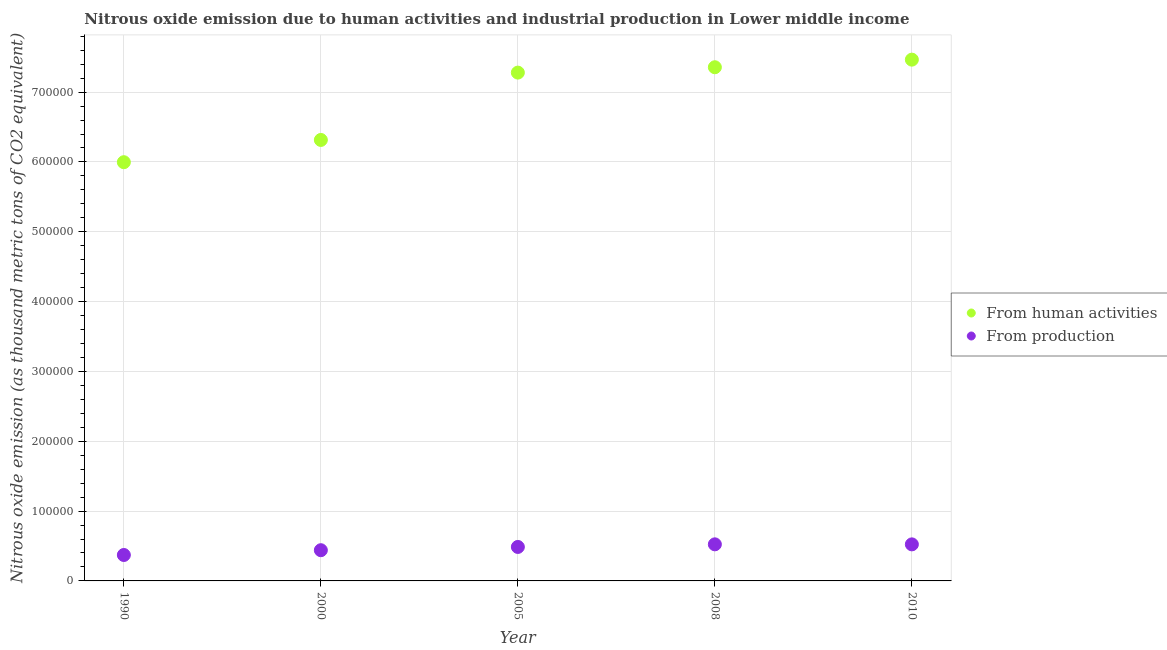What is the amount of emissions from human activities in 2000?
Your answer should be compact. 6.32e+05. Across all years, what is the maximum amount of emissions generated from industries?
Keep it short and to the point. 5.24e+04. Across all years, what is the minimum amount of emissions generated from industries?
Make the answer very short. 3.71e+04. What is the total amount of emissions from human activities in the graph?
Your answer should be very brief. 3.44e+06. What is the difference between the amount of emissions generated from industries in 2008 and that in 2010?
Provide a short and direct response. 45.3. What is the difference between the amount of emissions from human activities in 2010 and the amount of emissions generated from industries in 2005?
Your response must be concise. 6.98e+05. What is the average amount of emissions generated from industries per year?
Make the answer very short. 4.69e+04. In the year 2000, what is the difference between the amount of emissions generated from industries and amount of emissions from human activities?
Make the answer very short. -5.88e+05. In how many years, is the amount of emissions generated from industries greater than 740000 thousand metric tons?
Your answer should be very brief. 0. What is the ratio of the amount of emissions generated from industries in 2005 to that in 2010?
Give a very brief answer. 0.93. Is the amount of emissions from human activities in 2000 less than that in 2008?
Your response must be concise. Yes. What is the difference between the highest and the second highest amount of emissions from human activities?
Provide a succinct answer. 1.09e+04. What is the difference between the highest and the lowest amount of emissions from human activities?
Provide a succinct answer. 1.47e+05. In how many years, is the amount of emissions generated from industries greater than the average amount of emissions generated from industries taken over all years?
Your response must be concise. 3. Does the amount of emissions generated from industries monotonically increase over the years?
Offer a very short reply. No. Are the values on the major ticks of Y-axis written in scientific E-notation?
Offer a very short reply. No. Does the graph contain grids?
Make the answer very short. Yes. Where does the legend appear in the graph?
Keep it short and to the point. Center right. What is the title of the graph?
Your answer should be compact. Nitrous oxide emission due to human activities and industrial production in Lower middle income. What is the label or title of the Y-axis?
Ensure brevity in your answer.  Nitrous oxide emission (as thousand metric tons of CO2 equivalent). What is the Nitrous oxide emission (as thousand metric tons of CO2 equivalent) of From human activities in 1990?
Give a very brief answer. 6.00e+05. What is the Nitrous oxide emission (as thousand metric tons of CO2 equivalent) in From production in 1990?
Provide a short and direct response. 3.71e+04. What is the Nitrous oxide emission (as thousand metric tons of CO2 equivalent) of From human activities in 2000?
Make the answer very short. 6.32e+05. What is the Nitrous oxide emission (as thousand metric tons of CO2 equivalent) in From production in 2000?
Offer a very short reply. 4.40e+04. What is the Nitrous oxide emission (as thousand metric tons of CO2 equivalent) of From human activities in 2005?
Provide a succinct answer. 7.28e+05. What is the Nitrous oxide emission (as thousand metric tons of CO2 equivalent) in From production in 2005?
Make the answer very short. 4.87e+04. What is the Nitrous oxide emission (as thousand metric tons of CO2 equivalent) of From human activities in 2008?
Keep it short and to the point. 7.36e+05. What is the Nitrous oxide emission (as thousand metric tons of CO2 equivalent) of From production in 2008?
Offer a terse response. 5.24e+04. What is the Nitrous oxide emission (as thousand metric tons of CO2 equivalent) in From human activities in 2010?
Your answer should be very brief. 7.47e+05. What is the Nitrous oxide emission (as thousand metric tons of CO2 equivalent) of From production in 2010?
Give a very brief answer. 5.23e+04. Across all years, what is the maximum Nitrous oxide emission (as thousand metric tons of CO2 equivalent) of From human activities?
Provide a short and direct response. 7.47e+05. Across all years, what is the maximum Nitrous oxide emission (as thousand metric tons of CO2 equivalent) in From production?
Offer a terse response. 5.24e+04. Across all years, what is the minimum Nitrous oxide emission (as thousand metric tons of CO2 equivalent) of From human activities?
Ensure brevity in your answer.  6.00e+05. Across all years, what is the minimum Nitrous oxide emission (as thousand metric tons of CO2 equivalent) in From production?
Offer a very short reply. 3.71e+04. What is the total Nitrous oxide emission (as thousand metric tons of CO2 equivalent) in From human activities in the graph?
Keep it short and to the point. 3.44e+06. What is the total Nitrous oxide emission (as thousand metric tons of CO2 equivalent) of From production in the graph?
Provide a short and direct response. 2.35e+05. What is the difference between the Nitrous oxide emission (as thousand metric tons of CO2 equivalent) of From human activities in 1990 and that in 2000?
Your answer should be compact. -3.19e+04. What is the difference between the Nitrous oxide emission (as thousand metric tons of CO2 equivalent) in From production in 1990 and that in 2000?
Your answer should be compact. -6854.5. What is the difference between the Nitrous oxide emission (as thousand metric tons of CO2 equivalent) in From human activities in 1990 and that in 2005?
Keep it short and to the point. -1.28e+05. What is the difference between the Nitrous oxide emission (as thousand metric tons of CO2 equivalent) in From production in 1990 and that in 2005?
Your answer should be compact. -1.15e+04. What is the difference between the Nitrous oxide emission (as thousand metric tons of CO2 equivalent) of From human activities in 1990 and that in 2008?
Offer a very short reply. -1.36e+05. What is the difference between the Nitrous oxide emission (as thousand metric tons of CO2 equivalent) in From production in 1990 and that in 2008?
Provide a succinct answer. -1.53e+04. What is the difference between the Nitrous oxide emission (as thousand metric tons of CO2 equivalent) of From human activities in 1990 and that in 2010?
Your response must be concise. -1.47e+05. What is the difference between the Nitrous oxide emission (as thousand metric tons of CO2 equivalent) in From production in 1990 and that in 2010?
Offer a terse response. -1.52e+04. What is the difference between the Nitrous oxide emission (as thousand metric tons of CO2 equivalent) of From human activities in 2000 and that in 2005?
Provide a succinct answer. -9.64e+04. What is the difference between the Nitrous oxide emission (as thousand metric tons of CO2 equivalent) of From production in 2000 and that in 2005?
Your response must be concise. -4665.5. What is the difference between the Nitrous oxide emission (as thousand metric tons of CO2 equivalent) in From human activities in 2000 and that in 2008?
Offer a very short reply. -1.04e+05. What is the difference between the Nitrous oxide emission (as thousand metric tons of CO2 equivalent) in From production in 2000 and that in 2008?
Offer a terse response. -8400.2. What is the difference between the Nitrous oxide emission (as thousand metric tons of CO2 equivalent) in From human activities in 2000 and that in 2010?
Keep it short and to the point. -1.15e+05. What is the difference between the Nitrous oxide emission (as thousand metric tons of CO2 equivalent) of From production in 2000 and that in 2010?
Provide a short and direct response. -8354.9. What is the difference between the Nitrous oxide emission (as thousand metric tons of CO2 equivalent) in From human activities in 2005 and that in 2008?
Keep it short and to the point. -7685.1. What is the difference between the Nitrous oxide emission (as thousand metric tons of CO2 equivalent) in From production in 2005 and that in 2008?
Ensure brevity in your answer.  -3734.7. What is the difference between the Nitrous oxide emission (as thousand metric tons of CO2 equivalent) in From human activities in 2005 and that in 2010?
Offer a terse response. -1.86e+04. What is the difference between the Nitrous oxide emission (as thousand metric tons of CO2 equivalent) in From production in 2005 and that in 2010?
Offer a very short reply. -3689.4. What is the difference between the Nitrous oxide emission (as thousand metric tons of CO2 equivalent) of From human activities in 2008 and that in 2010?
Keep it short and to the point. -1.09e+04. What is the difference between the Nitrous oxide emission (as thousand metric tons of CO2 equivalent) of From production in 2008 and that in 2010?
Offer a very short reply. 45.3. What is the difference between the Nitrous oxide emission (as thousand metric tons of CO2 equivalent) of From human activities in 1990 and the Nitrous oxide emission (as thousand metric tons of CO2 equivalent) of From production in 2000?
Provide a succinct answer. 5.56e+05. What is the difference between the Nitrous oxide emission (as thousand metric tons of CO2 equivalent) of From human activities in 1990 and the Nitrous oxide emission (as thousand metric tons of CO2 equivalent) of From production in 2005?
Your response must be concise. 5.51e+05. What is the difference between the Nitrous oxide emission (as thousand metric tons of CO2 equivalent) in From human activities in 1990 and the Nitrous oxide emission (as thousand metric tons of CO2 equivalent) in From production in 2008?
Provide a short and direct response. 5.47e+05. What is the difference between the Nitrous oxide emission (as thousand metric tons of CO2 equivalent) in From human activities in 1990 and the Nitrous oxide emission (as thousand metric tons of CO2 equivalent) in From production in 2010?
Keep it short and to the point. 5.47e+05. What is the difference between the Nitrous oxide emission (as thousand metric tons of CO2 equivalent) of From human activities in 2000 and the Nitrous oxide emission (as thousand metric tons of CO2 equivalent) of From production in 2005?
Ensure brevity in your answer.  5.83e+05. What is the difference between the Nitrous oxide emission (as thousand metric tons of CO2 equivalent) in From human activities in 2000 and the Nitrous oxide emission (as thousand metric tons of CO2 equivalent) in From production in 2008?
Your answer should be compact. 5.79e+05. What is the difference between the Nitrous oxide emission (as thousand metric tons of CO2 equivalent) of From human activities in 2000 and the Nitrous oxide emission (as thousand metric tons of CO2 equivalent) of From production in 2010?
Your answer should be compact. 5.79e+05. What is the difference between the Nitrous oxide emission (as thousand metric tons of CO2 equivalent) of From human activities in 2005 and the Nitrous oxide emission (as thousand metric tons of CO2 equivalent) of From production in 2008?
Provide a succinct answer. 6.76e+05. What is the difference between the Nitrous oxide emission (as thousand metric tons of CO2 equivalent) in From human activities in 2005 and the Nitrous oxide emission (as thousand metric tons of CO2 equivalent) in From production in 2010?
Give a very brief answer. 6.76e+05. What is the difference between the Nitrous oxide emission (as thousand metric tons of CO2 equivalent) of From human activities in 2008 and the Nitrous oxide emission (as thousand metric tons of CO2 equivalent) of From production in 2010?
Ensure brevity in your answer.  6.83e+05. What is the average Nitrous oxide emission (as thousand metric tons of CO2 equivalent) in From human activities per year?
Offer a terse response. 6.88e+05. What is the average Nitrous oxide emission (as thousand metric tons of CO2 equivalent) of From production per year?
Your answer should be very brief. 4.69e+04. In the year 1990, what is the difference between the Nitrous oxide emission (as thousand metric tons of CO2 equivalent) in From human activities and Nitrous oxide emission (as thousand metric tons of CO2 equivalent) in From production?
Your answer should be very brief. 5.63e+05. In the year 2000, what is the difference between the Nitrous oxide emission (as thousand metric tons of CO2 equivalent) of From human activities and Nitrous oxide emission (as thousand metric tons of CO2 equivalent) of From production?
Offer a very short reply. 5.88e+05. In the year 2005, what is the difference between the Nitrous oxide emission (as thousand metric tons of CO2 equivalent) in From human activities and Nitrous oxide emission (as thousand metric tons of CO2 equivalent) in From production?
Offer a very short reply. 6.79e+05. In the year 2008, what is the difference between the Nitrous oxide emission (as thousand metric tons of CO2 equivalent) in From human activities and Nitrous oxide emission (as thousand metric tons of CO2 equivalent) in From production?
Make the answer very short. 6.83e+05. In the year 2010, what is the difference between the Nitrous oxide emission (as thousand metric tons of CO2 equivalent) of From human activities and Nitrous oxide emission (as thousand metric tons of CO2 equivalent) of From production?
Provide a succinct answer. 6.94e+05. What is the ratio of the Nitrous oxide emission (as thousand metric tons of CO2 equivalent) of From human activities in 1990 to that in 2000?
Your answer should be very brief. 0.95. What is the ratio of the Nitrous oxide emission (as thousand metric tons of CO2 equivalent) of From production in 1990 to that in 2000?
Your response must be concise. 0.84. What is the ratio of the Nitrous oxide emission (as thousand metric tons of CO2 equivalent) of From human activities in 1990 to that in 2005?
Offer a terse response. 0.82. What is the ratio of the Nitrous oxide emission (as thousand metric tons of CO2 equivalent) in From production in 1990 to that in 2005?
Provide a short and direct response. 0.76. What is the ratio of the Nitrous oxide emission (as thousand metric tons of CO2 equivalent) of From human activities in 1990 to that in 2008?
Make the answer very short. 0.82. What is the ratio of the Nitrous oxide emission (as thousand metric tons of CO2 equivalent) of From production in 1990 to that in 2008?
Your response must be concise. 0.71. What is the ratio of the Nitrous oxide emission (as thousand metric tons of CO2 equivalent) in From human activities in 1990 to that in 2010?
Your response must be concise. 0.8. What is the ratio of the Nitrous oxide emission (as thousand metric tons of CO2 equivalent) in From production in 1990 to that in 2010?
Offer a terse response. 0.71. What is the ratio of the Nitrous oxide emission (as thousand metric tons of CO2 equivalent) of From human activities in 2000 to that in 2005?
Your answer should be compact. 0.87. What is the ratio of the Nitrous oxide emission (as thousand metric tons of CO2 equivalent) of From production in 2000 to that in 2005?
Ensure brevity in your answer.  0.9. What is the ratio of the Nitrous oxide emission (as thousand metric tons of CO2 equivalent) in From human activities in 2000 to that in 2008?
Ensure brevity in your answer.  0.86. What is the ratio of the Nitrous oxide emission (as thousand metric tons of CO2 equivalent) of From production in 2000 to that in 2008?
Give a very brief answer. 0.84. What is the ratio of the Nitrous oxide emission (as thousand metric tons of CO2 equivalent) of From human activities in 2000 to that in 2010?
Offer a terse response. 0.85. What is the ratio of the Nitrous oxide emission (as thousand metric tons of CO2 equivalent) in From production in 2000 to that in 2010?
Ensure brevity in your answer.  0.84. What is the ratio of the Nitrous oxide emission (as thousand metric tons of CO2 equivalent) of From production in 2005 to that in 2008?
Provide a short and direct response. 0.93. What is the ratio of the Nitrous oxide emission (as thousand metric tons of CO2 equivalent) of From human activities in 2005 to that in 2010?
Your response must be concise. 0.98. What is the ratio of the Nitrous oxide emission (as thousand metric tons of CO2 equivalent) in From production in 2005 to that in 2010?
Ensure brevity in your answer.  0.93. What is the ratio of the Nitrous oxide emission (as thousand metric tons of CO2 equivalent) in From human activities in 2008 to that in 2010?
Ensure brevity in your answer.  0.99. What is the difference between the highest and the second highest Nitrous oxide emission (as thousand metric tons of CO2 equivalent) of From human activities?
Offer a very short reply. 1.09e+04. What is the difference between the highest and the second highest Nitrous oxide emission (as thousand metric tons of CO2 equivalent) of From production?
Ensure brevity in your answer.  45.3. What is the difference between the highest and the lowest Nitrous oxide emission (as thousand metric tons of CO2 equivalent) of From human activities?
Keep it short and to the point. 1.47e+05. What is the difference between the highest and the lowest Nitrous oxide emission (as thousand metric tons of CO2 equivalent) in From production?
Provide a succinct answer. 1.53e+04. 